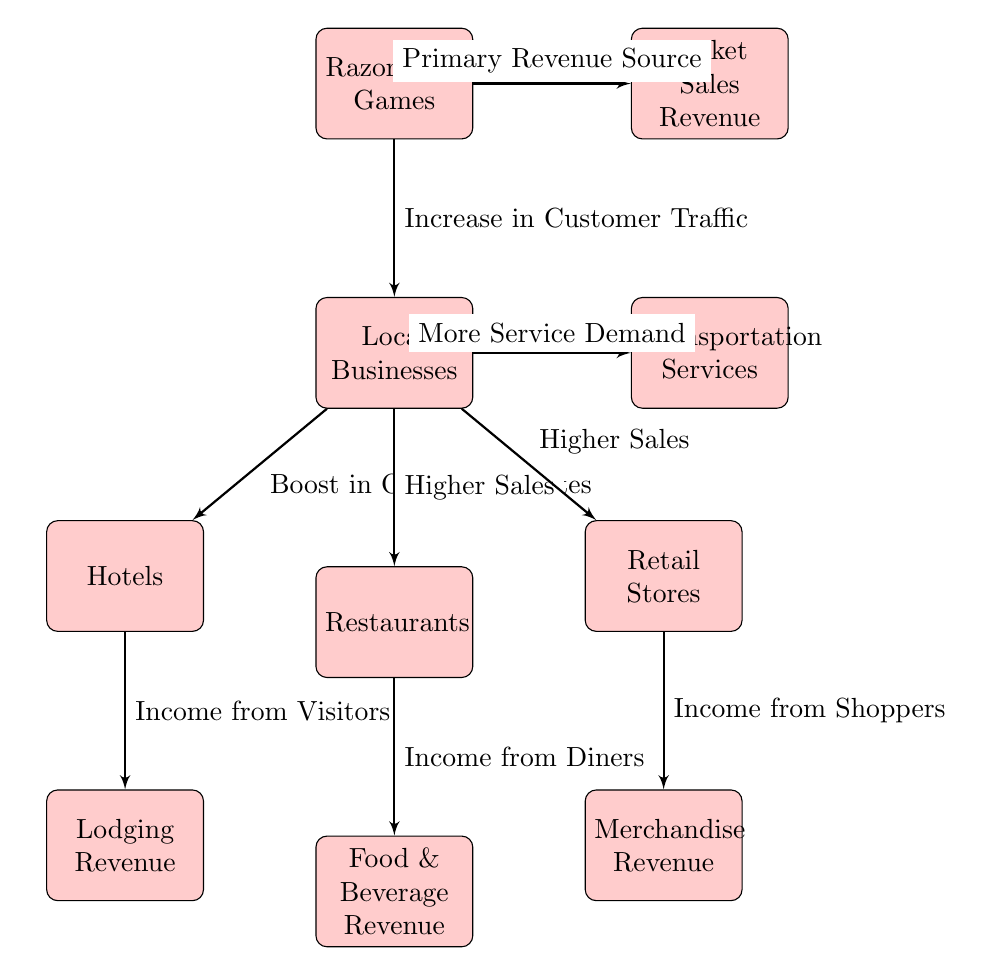What are the main local businesses impacted by Razorbacks games? The diagram shows three main categories of local businesses impacted by Razorbacks games: hotels, restaurants, and retail stores. These are directly connected to the "Local Businesses" node.
Answer: Hotels, Restaurants, Retail Stores How does Razorbacks games affect ticket sales revenue? The ticket sales revenue is identified as a primary revenue source, which is directly connected to Razorbacks games. The diagram indicates that Razorbacks games have a direct impact on ticket sales revenue.
Answer: Primary Revenue Source What type of revenue does the restaurant business generate from Razorbacks games? The diagram indicates that restaurants generate "Food & Beverage Revenue" which is connected to the "Higher Sales" relationship from "Local Businesses."
Answer: Food & Beverage Revenue What effect do Razorbacks games have on hotels? There is a relationship indicating "Boost in Occupancy Rates" from "Local Businesses" to hotels, suggesting that Razorbacks games increase the number of guests, thus positively affecting hotel occupancy.
Answer: Boost in Occupancy Rates How many nodes are there related to the revenue sources from local businesses? The diagram includes three revenue sources from local businesses: lodging, food & beverage, and merchandise revenue. Therefore, there are three nodes specifically related to revenue sources.
Answer: 3 What does the "Transportation Services" block represent in the context of Razorbacks games? The "Transportation Services" block represents the "More Service Demand" resulting from Razorbacks games, indicating that games create a higher demand for transport options.
Answer: More Service Demand What causes the increase in customer traffic to local businesses during Razorbacks games? The increase in customer traffic is caused by Razorbacks games, as indicated by the connecting line from "Razorbacks Games" to "Local Businesses" which shows their direct influence on customer flow.
Answer: Increase in Customer Traffic Which node represents lodging revenue in the diagram? The "Lodging Revenue" node is located below the "Hotels" block in the diagram, indicating that it is a source of revenue generated by the hotel businesses during the Razorbacks games' events.
Answer: Lodging Revenue 